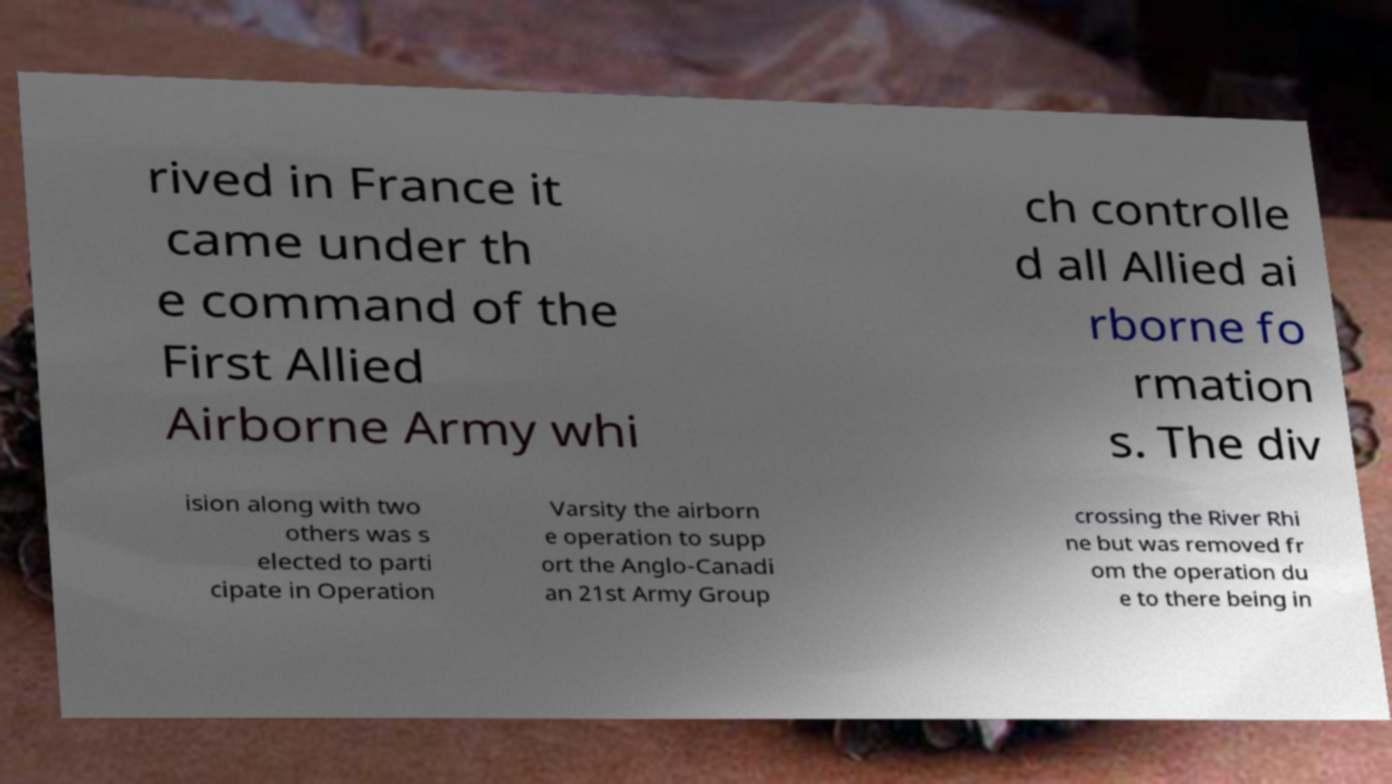Please read and relay the text visible in this image. What does it say? rived in France it came under th e command of the First Allied Airborne Army whi ch controlle d all Allied ai rborne fo rmation s. The div ision along with two others was s elected to parti cipate in Operation Varsity the airborn e operation to supp ort the Anglo-Canadi an 21st Army Group crossing the River Rhi ne but was removed fr om the operation du e to there being in 